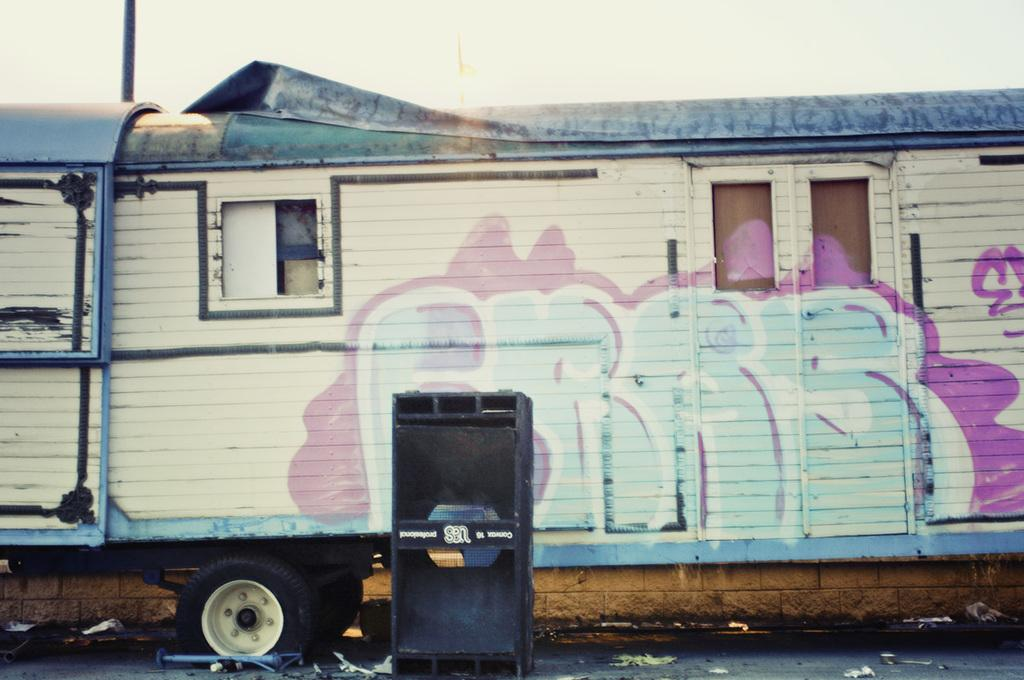What is the main subject of the image? The main subject of the image is a train. What other objects can be seen in the image? There is a sound box, a window, and a door visible in the image. What is visible in the background of the image? The sky is visible in the image. Can you tell me how many berries are on the train in the image? There are no berries present in the image; it features a train, a sound box, a window, and a door. What hope does the train symbolize in the image? The image does not convey any symbolism or emotions related to hope; it simply depicts a train and other objects. 